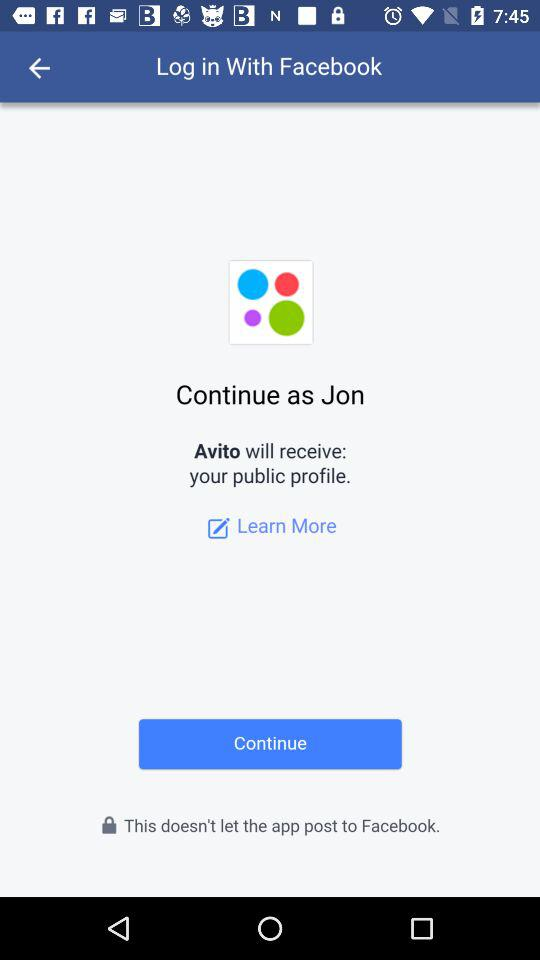Who will receive the profile? The profile will be received by "Avito". 